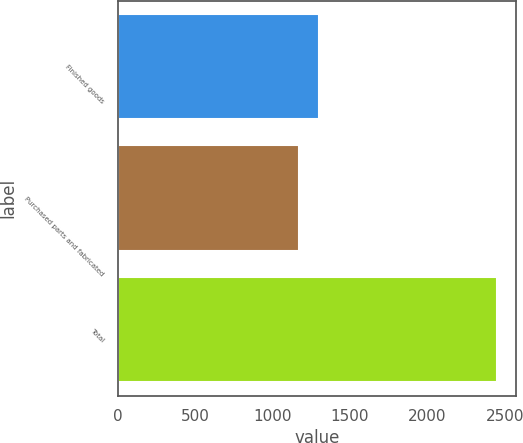<chart> <loc_0><loc_0><loc_500><loc_500><bar_chart><fcel>Finished goods<fcel>Purchased parts and fabricated<fcel>Total<nl><fcel>1300.4<fcel>1173<fcel>2447<nl></chart> 